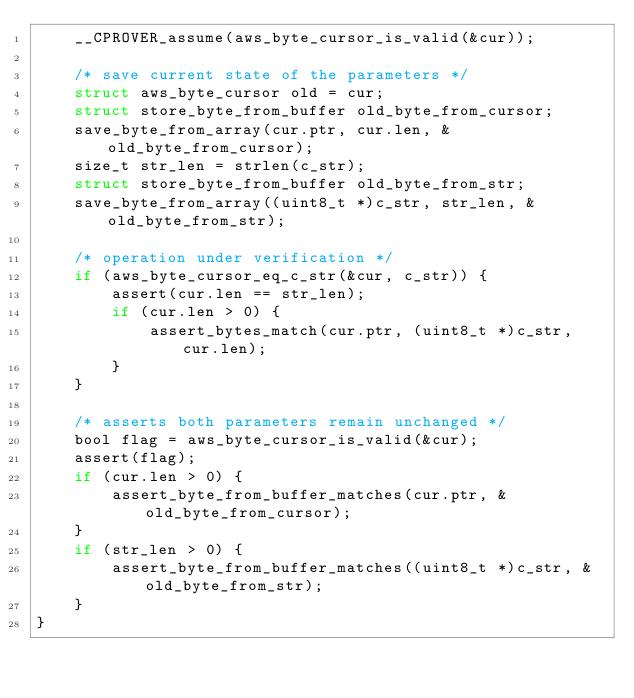Convert code to text. <code><loc_0><loc_0><loc_500><loc_500><_C_>    __CPROVER_assume(aws_byte_cursor_is_valid(&cur));

    /* save current state of the parameters */
    struct aws_byte_cursor old = cur;
    struct store_byte_from_buffer old_byte_from_cursor;
    save_byte_from_array(cur.ptr, cur.len, &old_byte_from_cursor);
    size_t str_len = strlen(c_str);
    struct store_byte_from_buffer old_byte_from_str;
    save_byte_from_array((uint8_t *)c_str, str_len, &old_byte_from_str);

    /* operation under verification */
    if (aws_byte_cursor_eq_c_str(&cur, c_str)) {
        assert(cur.len == str_len);
        if (cur.len > 0) {
            assert_bytes_match(cur.ptr, (uint8_t *)c_str, cur.len);
        }
    }

    /* asserts both parameters remain unchanged */
    bool flag = aws_byte_cursor_is_valid(&cur);
    assert(flag);
    if (cur.len > 0) {
        assert_byte_from_buffer_matches(cur.ptr, &old_byte_from_cursor);
    }
    if (str_len > 0) {
        assert_byte_from_buffer_matches((uint8_t *)c_str, &old_byte_from_str);
    }
}
</code> 